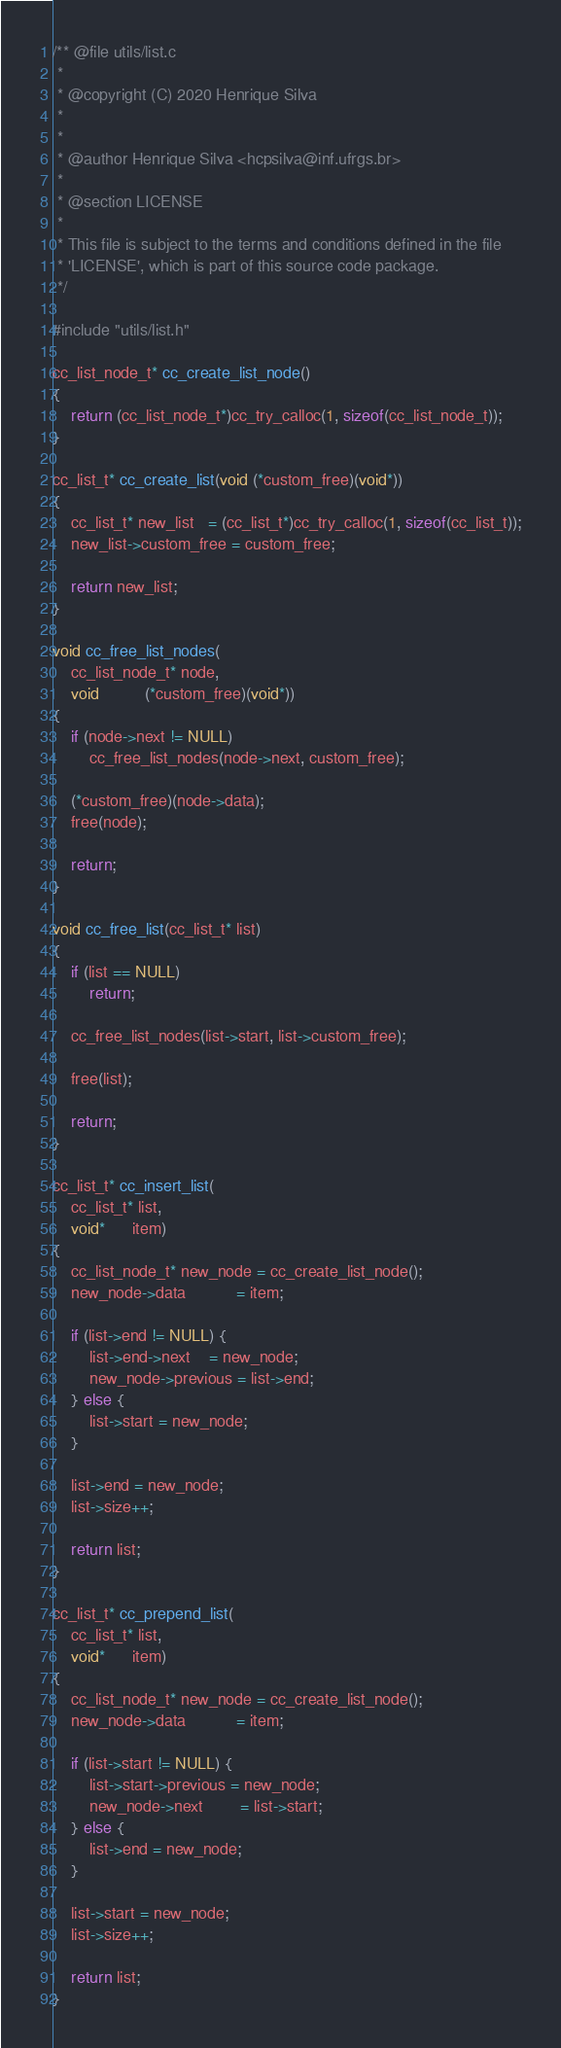Convert code to text. <code><loc_0><loc_0><loc_500><loc_500><_C_>/** @file utils/list.c
 *
 * @copyright (C) 2020 Henrique Silva
 *
 *
 * @author Henrique Silva <hcpsilva@inf.ufrgs.br>
 *
 * @section LICENSE
 *
 * This file is subject to the terms and conditions defined in the file
 * 'LICENSE', which is part of this source code package.
 */

#include "utils/list.h"

cc_list_node_t* cc_create_list_node()
{
    return (cc_list_node_t*)cc_try_calloc(1, sizeof(cc_list_node_t));
}

cc_list_t* cc_create_list(void (*custom_free)(void*))
{
    cc_list_t* new_list   = (cc_list_t*)cc_try_calloc(1, sizeof(cc_list_t));
    new_list->custom_free = custom_free;

    return new_list;
}

void cc_free_list_nodes(
    cc_list_node_t* node,
    void          (*custom_free)(void*))
{
    if (node->next != NULL)
        cc_free_list_nodes(node->next, custom_free);

    (*custom_free)(node->data);
    free(node);

    return;
}

void cc_free_list(cc_list_t* list)
{
    if (list == NULL)
        return;

    cc_free_list_nodes(list->start, list->custom_free);

    free(list);

    return;
}

cc_list_t* cc_insert_list(
    cc_list_t* list,
    void*      item)
{
    cc_list_node_t* new_node = cc_create_list_node();
    new_node->data           = item;

    if (list->end != NULL) {
        list->end->next    = new_node;
        new_node->previous = list->end;
    } else {
        list->start = new_node;
    }

    list->end = new_node;
    list->size++;

    return list;
}

cc_list_t* cc_prepend_list(
    cc_list_t* list,
    void*      item)
{
    cc_list_node_t* new_node = cc_create_list_node();
    new_node->data           = item;

    if (list->start != NULL) {
        list->start->previous = new_node;
        new_node->next        = list->start;
    } else {
        list->end = new_node;
    }

    list->start = new_node;
    list->size++;

    return list;
}
</code> 